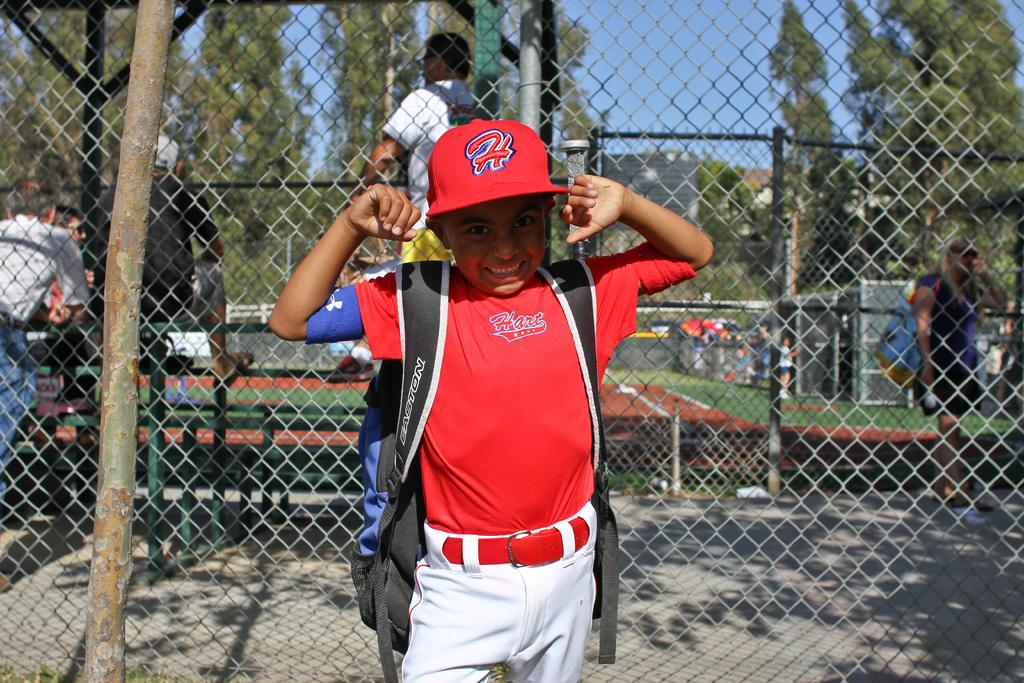<image>
Render a clear and concise summary of the photo. A boy in a shirt that says "Hart" poses near a fence. 